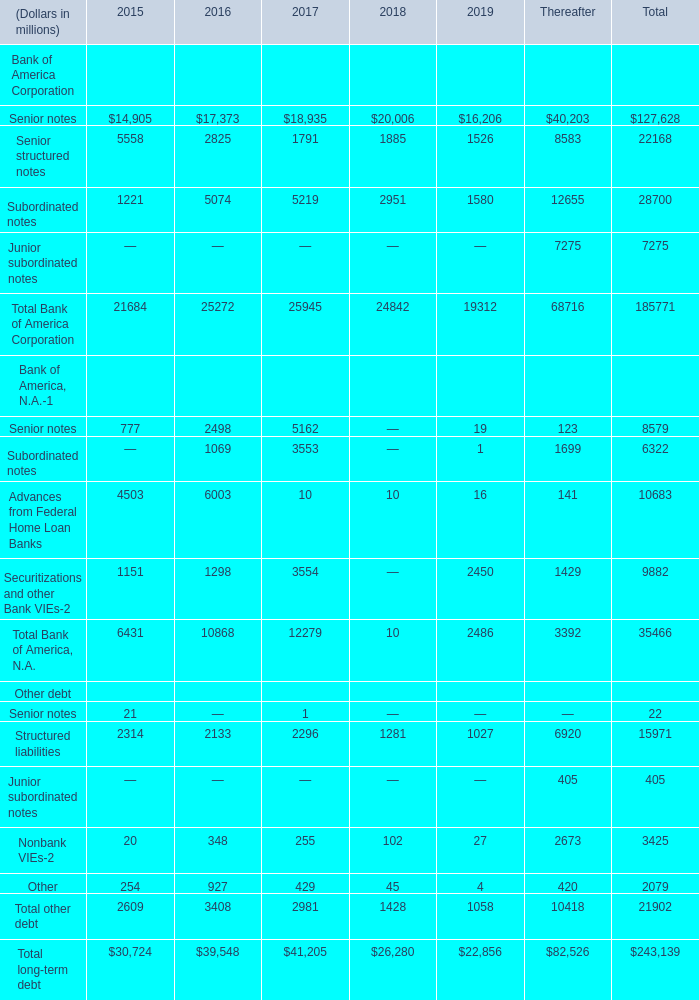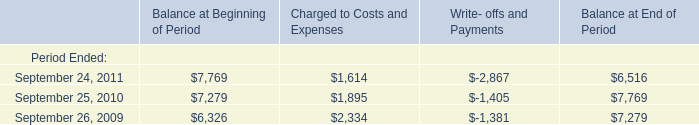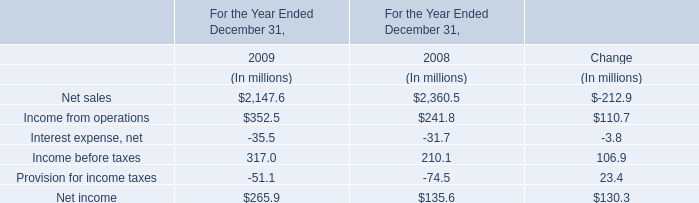What is the total amount of Senior structured notes of Thereafter, September 26, 2009 of Balance at Beginning of Period, and Securitizations and other Bank VIEs Bank of America, N.A. of Total ? 
Computations: ((8583.0 + 6326.0) + 9882.0)
Answer: 24791.0. 